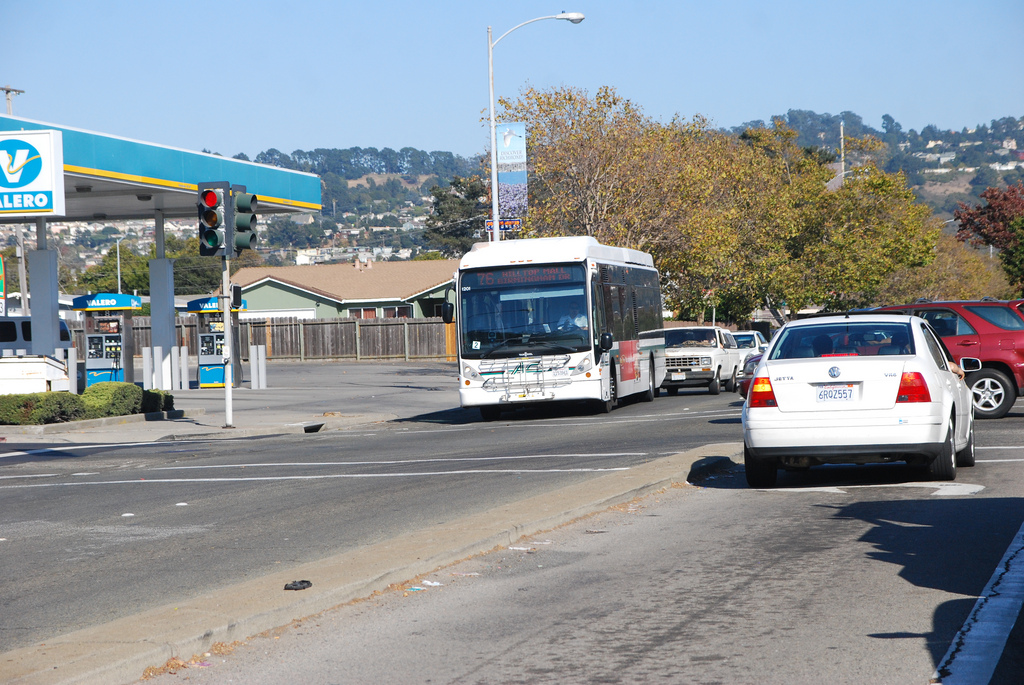What vehicle is to the left of the car? A white bus with an advertisement for '76' on the side is visible to the left of the white car. 